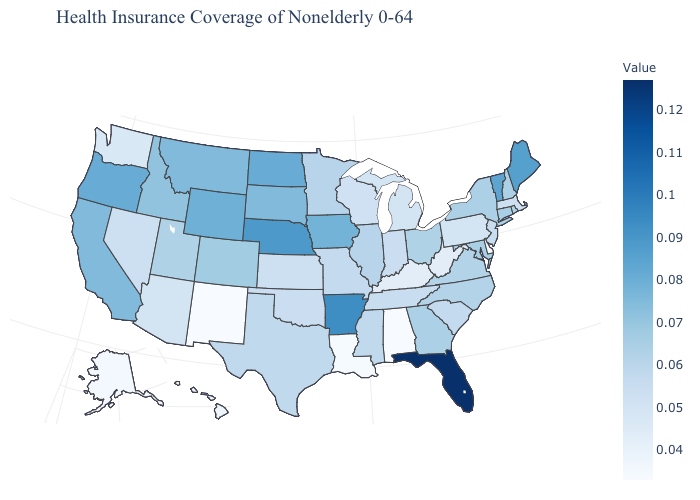Which states have the lowest value in the Northeast?
Answer briefly. Pennsylvania. Which states have the highest value in the USA?
Keep it brief. Florida. Does West Virginia have a higher value than Alabama?
Answer briefly. Yes. Which states have the highest value in the USA?
Keep it brief. Florida. Does the map have missing data?
Short answer required. No. 